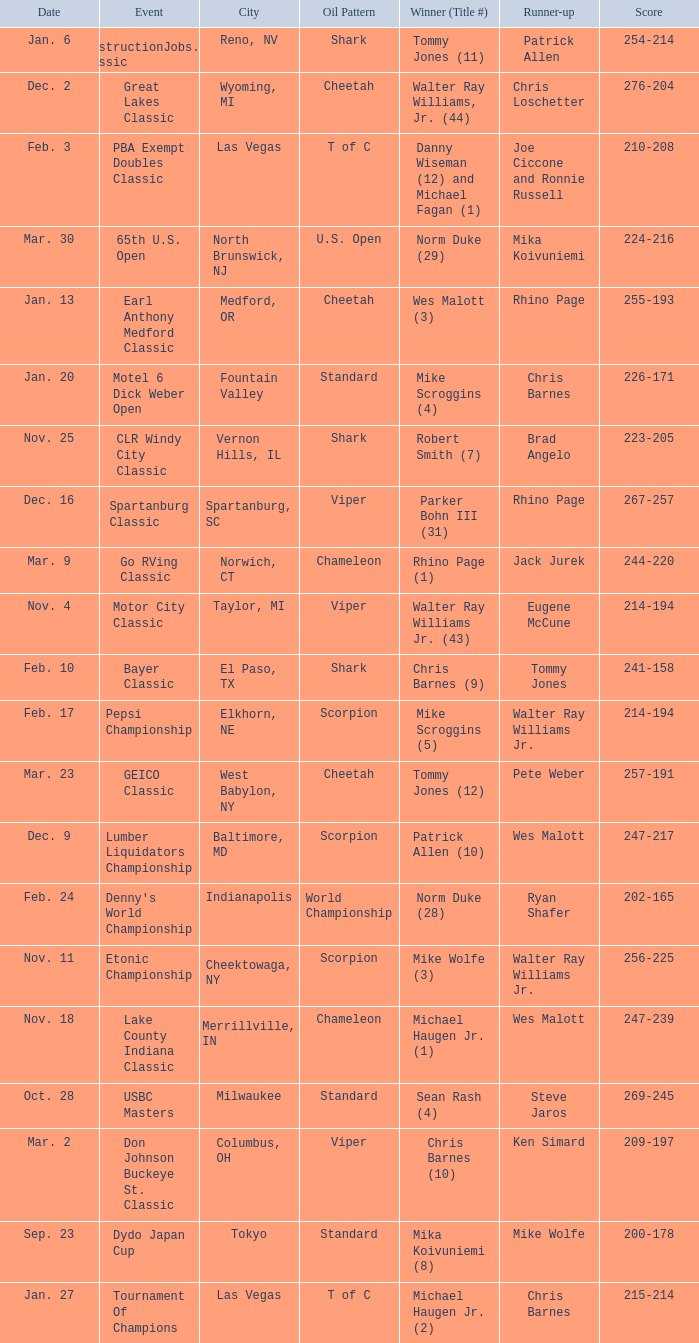Name the Event which has a Score of 209-197? Don Johnson Buckeye St. Classic. 